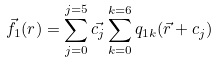<formula> <loc_0><loc_0><loc_500><loc_500>\vec { f _ { 1 } } ( r ) = \sum _ { j = 0 } ^ { j = 5 } \vec { c _ { j } } \sum _ { k = 0 } ^ { k = 6 } q _ { 1 k } ( \vec { r } + c _ { j } )</formula> 